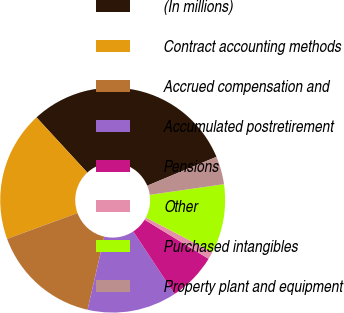<chart> <loc_0><loc_0><loc_500><loc_500><pie_chart><fcel>(In millions)<fcel>Contract accounting methods<fcel>Accrued compensation and<fcel>Accumulated postretirement<fcel>Pensions<fcel>Other<fcel>Purchased intangibles<fcel>Property plant and equipment<nl><fcel>30.55%<fcel>18.76%<fcel>15.81%<fcel>12.87%<fcel>6.98%<fcel>1.08%<fcel>9.92%<fcel>4.03%<nl></chart> 